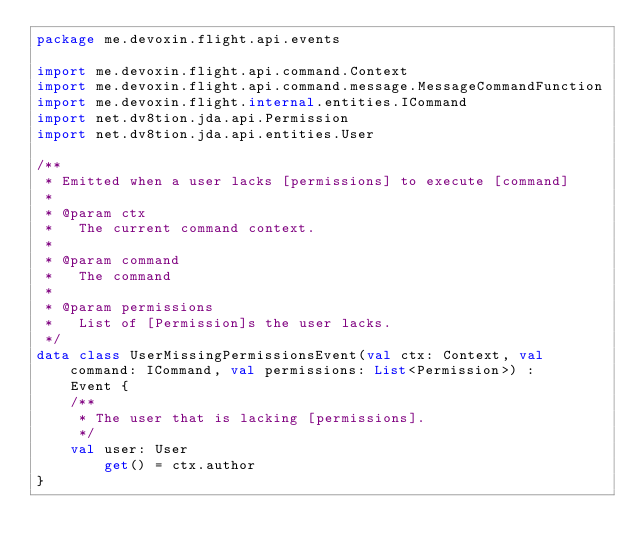<code> <loc_0><loc_0><loc_500><loc_500><_Kotlin_>package me.devoxin.flight.api.events

import me.devoxin.flight.api.command.Context
import me.devoxin.flight.api.command.message.MessageCommandFunction
import me.devoxin.flight.internal.entities.ICommand
import net.dv8tion.jda.api.Permission
import net.dv8tion.jda.api.entities.User

/**
 * Emitted when a user lacks [permissions] to execute [command]
 *
 * @param ctx
 *   The current command context.
 *
 * @param command
 *   The command
 *
 * @param permissions
 *   List of [Permission]s the user lacks.
 */
data class UserMissingPermissionsEvent(val ctx: Context, val command: ICommand, val permissions: List<Permission>) :
    Event {
    /**
     * The user that is lacking [permissions].
     */
    val user: User
        get() = ctx.author
}
</code> 